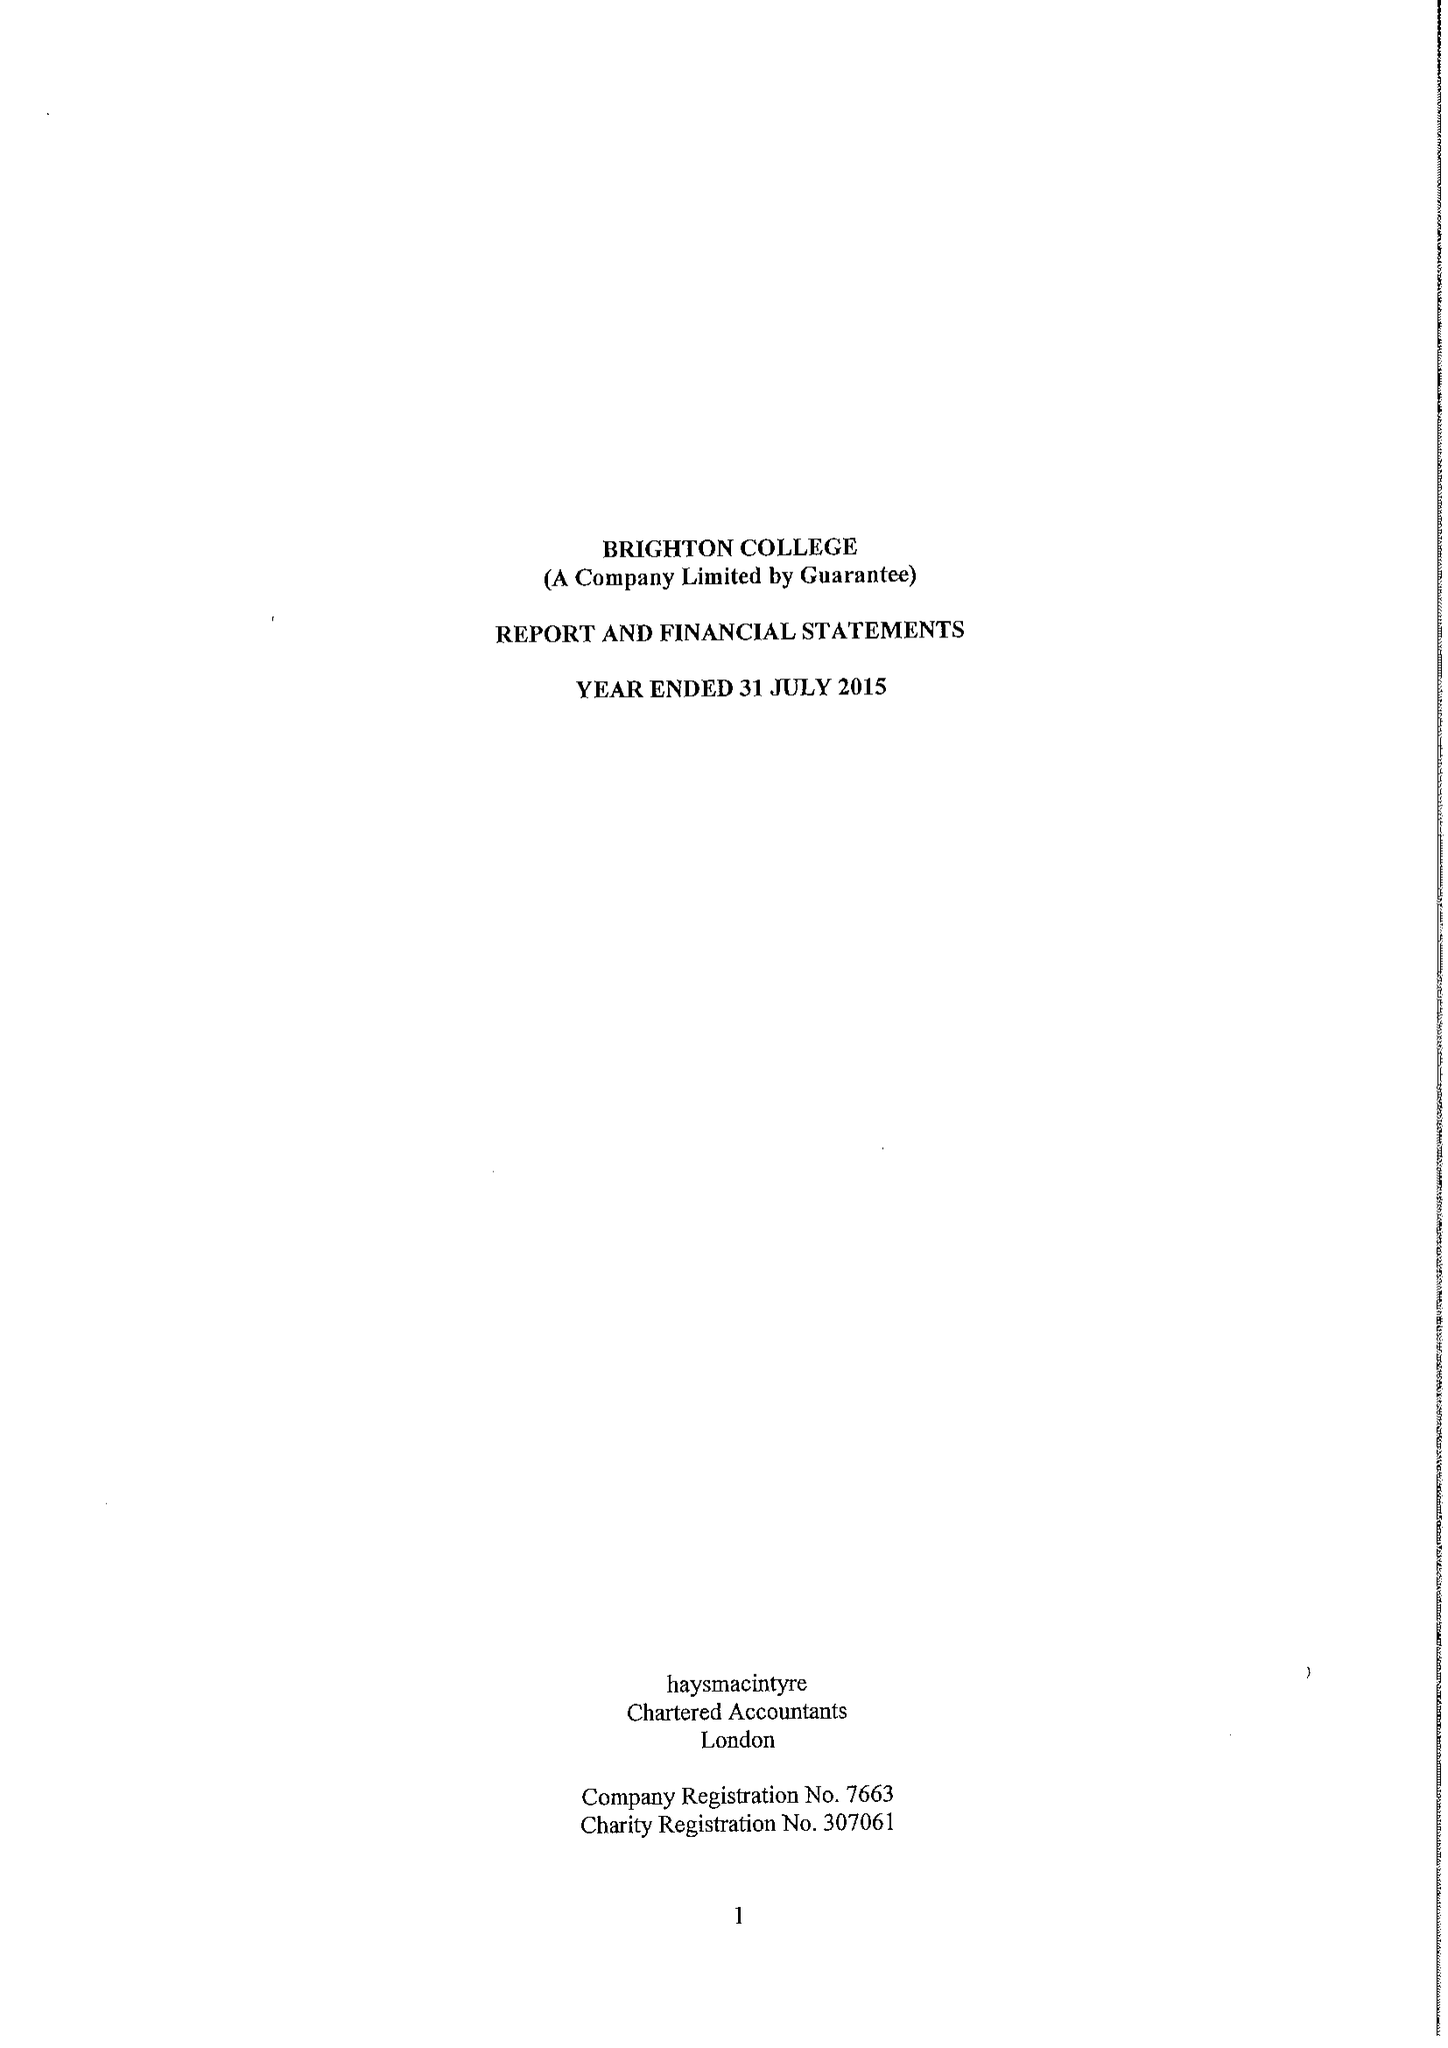What is the value for the charity_name?
Answer the question using a single word or phrase. Brighton College 